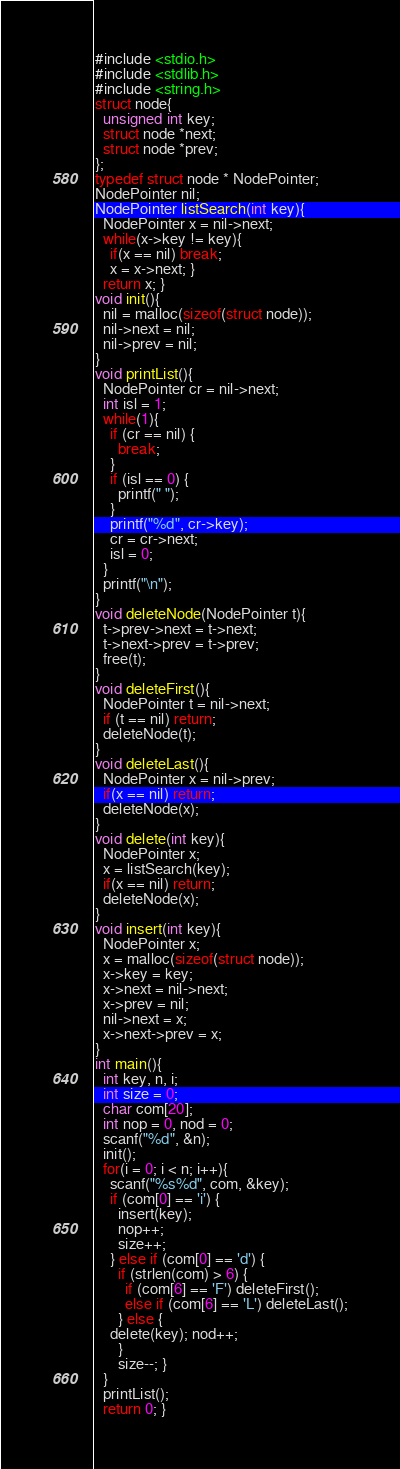Convert code to text. <code><loc_0><loc_0><loc_500><loc_500><_C_>#include <stdio.h>
#include <stdlib.h>
#include <string.h>
struct node{
  unsigned int key;
  struct node *next;
  struct node *prev;
};
typedef struct node * NodePointer;
NodePointer nil;
NodePointer listSearch(int key){
  NodePointer x = nil->next;
  while(x->key != key){
    if(x == nil) break;
    x = x->next; }
  return x; }
void init(){
  nil = malloc(sizeof(struct node));
  nil->next = nil;
  nil->prev = nil;
}
void printList(){
  NodePointer cr = nil->next;
  int isl = 1;
  while(1){
    if (cr == nil) {
      break;
    }
    if (isl == 0) {
      printf(" ");
    }
    printf("%d", cr->key);
    cr = cr->next;
    isl = 0;
  }
  printf("\n");
}
void deleteNode(NodePointer t){
  t->prev->next = t->next;
  t->next->prev = t->prev;
  free(t);
}
void deleteFirst(){
  NodePointer t = nil->next;
  if (t == nil) return;
  deleteNode(t);
}
void deleteLast(){
  NodePointer x = nil->prev;
  if(x == nil) return;
  deleteNode(x);
}
void delete(int key){
  NodePointer x;
  x = listSearch(key);
  if(x == nil) return;
  deleteNode(x);
}
void insert(int key){
  NodePointer x;
  x = malloc(sizeof(struct node));
  x->key = key;
  x->next = nil->next;
  x->prev = nil;
  nil->next = x;
  x->next->prev = x;
}
int main(){
  int key, n, i;
  int size = 0;
  char com[20];
  int nop = 0, nod = 0;
  scanf("%d", &n);
  init();
  for(i = 0; i < n; i++){
    scanf("%s%d", com, &key);
    if (com[0] == 'i') {
      insert(key);
      nop++;
      size++;
    } else if (com[0] == 'd') {
      if (strlen(com) > 6) {
        if (com[6] == 'F') deleteFirst();
        else if (com[6] == 'L') deleteLast();
      } else {
	delete(key); nod++;
      }
      size--; }
  }
  printList();
  return 0; }

</code> 